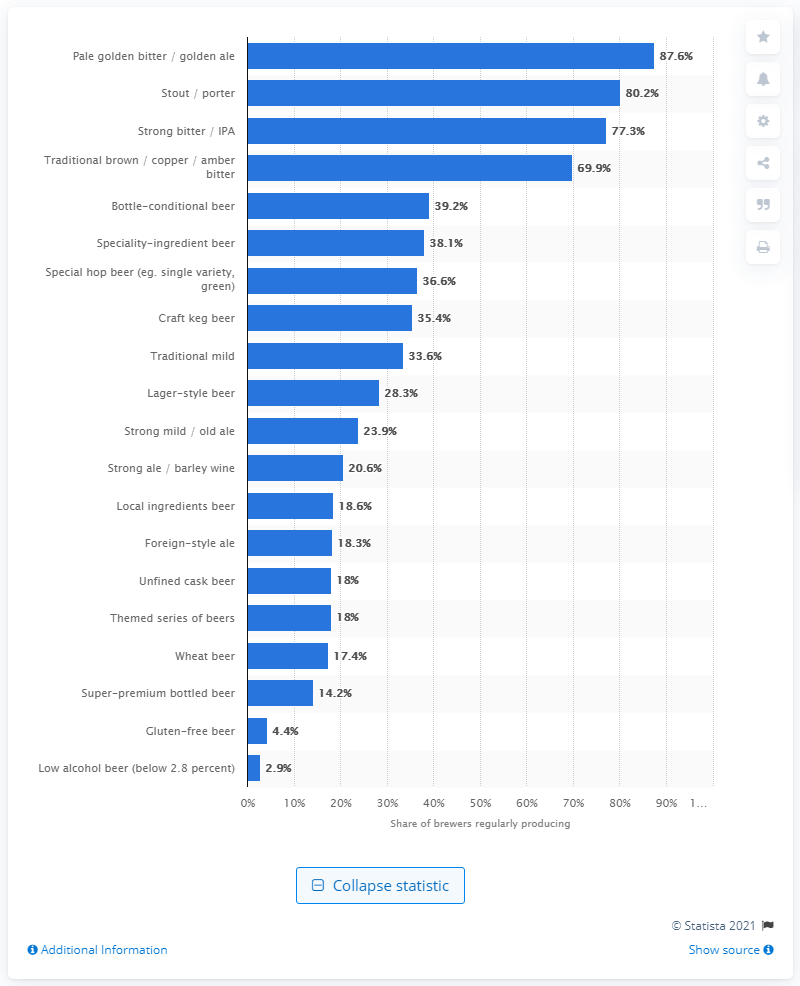List a handful of essential elements in this visual. According to a recent survey, about 77.3% of independent brewers produce strong bitter or IPA, indicating a growing trend in the craft beer industry towards hoppier and more full-flavored beers. According to a recent study, 80.2% of independent brewers produce stout or porter beer. In 2016, the most popular style of beer produced by independent brewers in the UK was pale golden bitter/golden ale. 